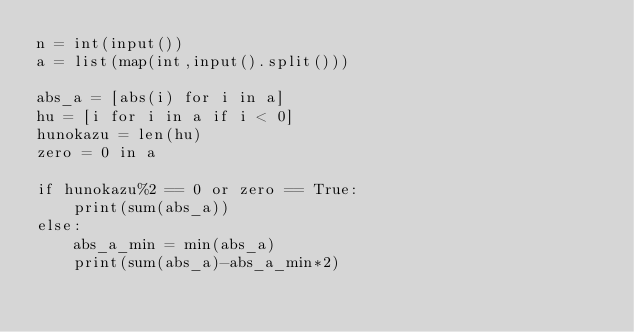Convert code to text. <code><loc_0><loc_0><loc_500><loc_500><_Python_>n = int(input())
a = list(map(int,input().split()))

abs_a = [abs(i) for i in a]
hu = [i for i in a if i < 0]
hunokazu = len(hu)
zero = 0 in a

if hunokazu%2 == 0 or zero == True:
    print(sum(abs_a))
else:
    abs_a_min = min(abs_a)
    print(sum(abs_a)-abs_a_min*2)
</code> 